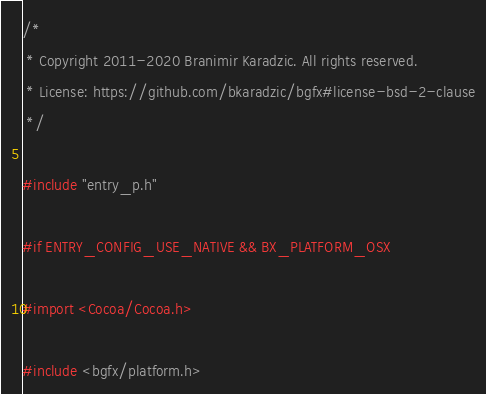<code> <loc_0><loc_0><loc_500><loc_500><_ObjectiveC_>/*
 * Copyright 2011-2020 Branimir Karadzic. All rights reserved.
 * License: https://github.com/bkaradzic/bgfx#license-bsd-2-clause
 */

#include "entry_p.h"

#if ENTRY_CONFIG_USE_NATIVE && BX_PLATFORM_OSX

#import <Cocoa/Cocoa.h>

#include <bgfx/platform.h>
</code> 